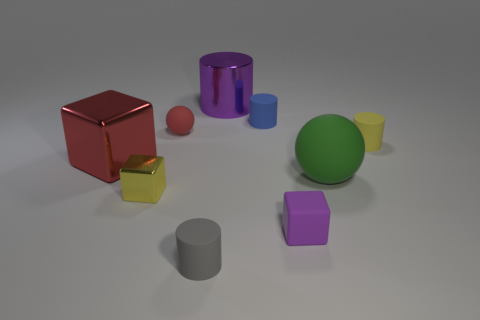Add 1 small blue metallic spheres. How many objects exist? 10 Subtract all cylinders. How many objects are left? 5 Add 9 small yellow matte blocks. How many small yellow matte blocks exist? 9 Subtract 0 green cylinders. How many objects are left? 9 Subtract all large brown cylinders. Subtract all red things. How many objects are left? 7 Add 7 large rubber balls. How many large rubber balls are left? 8 